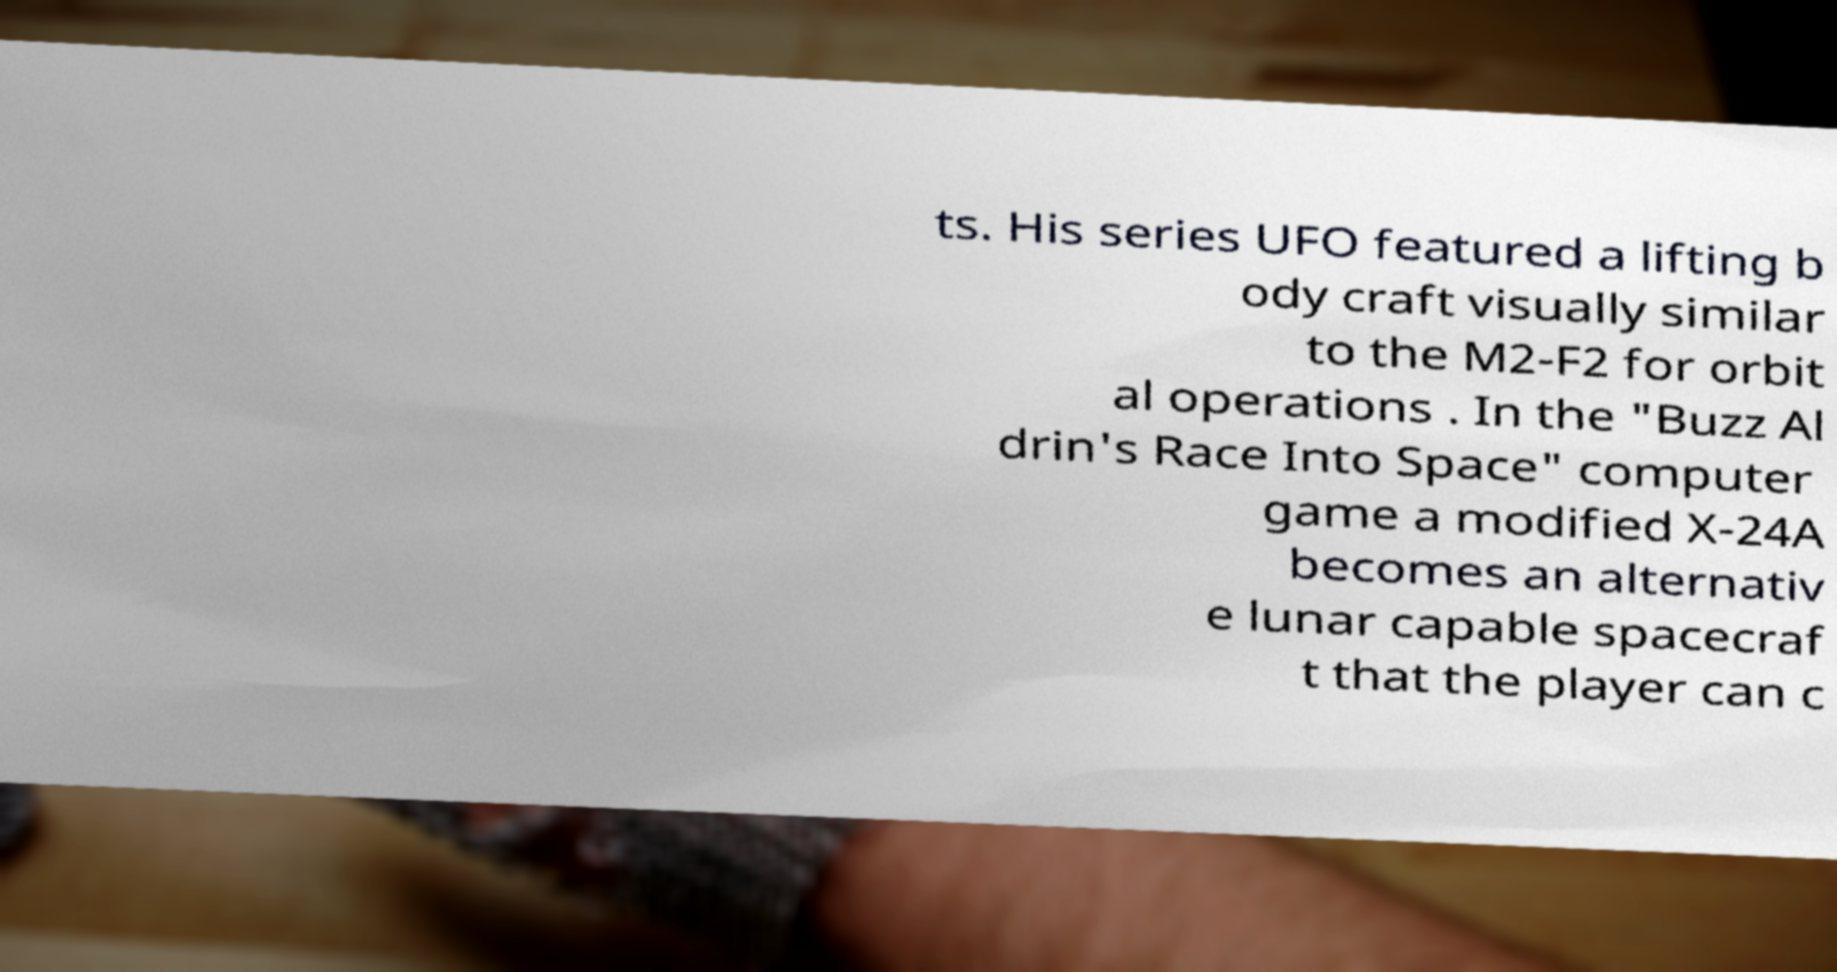Can you read and provide the text displayed in the image?This photo seems to have some interesting text. Can you extract and type it out for me? ts. His series UFO featured a lifting b ody craft visually similar to the M2-F2 for orbit al operations . In the "Buzz Al drin's Race Into Space" computer game a modified X-24A becomes an alternativ e lunar capable spacecraf t that the player can c 